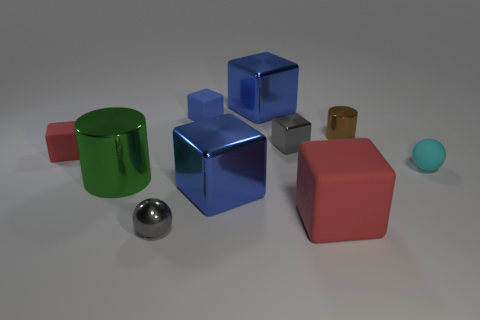How many blue blocks must be subtracted to get 1 blue blocks? 2 Subtract all cyan spheres. How many blue cubes are left? 3 Subtract all red cubes. How many cubes are left? 4 Subtract all big red matte blocks. How many blocks are left? 5 Subtract all red blocks. Subtract all cyan cylinders. How many blocks are left? 4 Subtract all cubes. How many objects are left? 4 Add 8 brown shiny cylinders. How many brown shiny cylinders exist? 9 Subtract 0 cyan cylinders. How many objects are left? 10 Subtract all gray cubes. Subtract all rubber spheres. How many objects are left? 8 Add 4 tiny brown objects. How many tiny brown objects are left? 5 